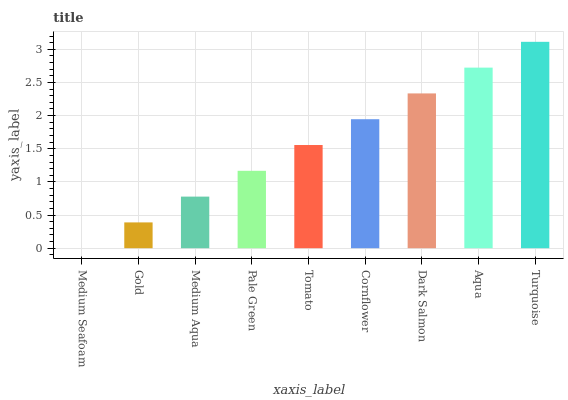Is Medium Seafoam the minimum?
Answer yes or no. Yes. Is Turquoise the maximum?
Answer yes or no. Yes. Is Gold the minimum?
Answer yes or no. No. Is Gold the maximum?
Answer yes or no. No. Is Gold greater than Medium Seafoam?
Answer yes or no. Yes. Is Medium Seafoam less than Gold?
Answer yes or no. Yes. Is Medium Seafoam greater than Gold?
Answer yes or no. No. Is Gold less than Medium Seafoam?
Answer yes or no. No. Is Tomato the high median?
Answer yes or no. Yes. Is Tomato the low median?
Answer yes or no. Yes. Is Gold the high median?
Answer yes or no. No. Is Medium Seafoam the low median?
Answer yes or no. No. 